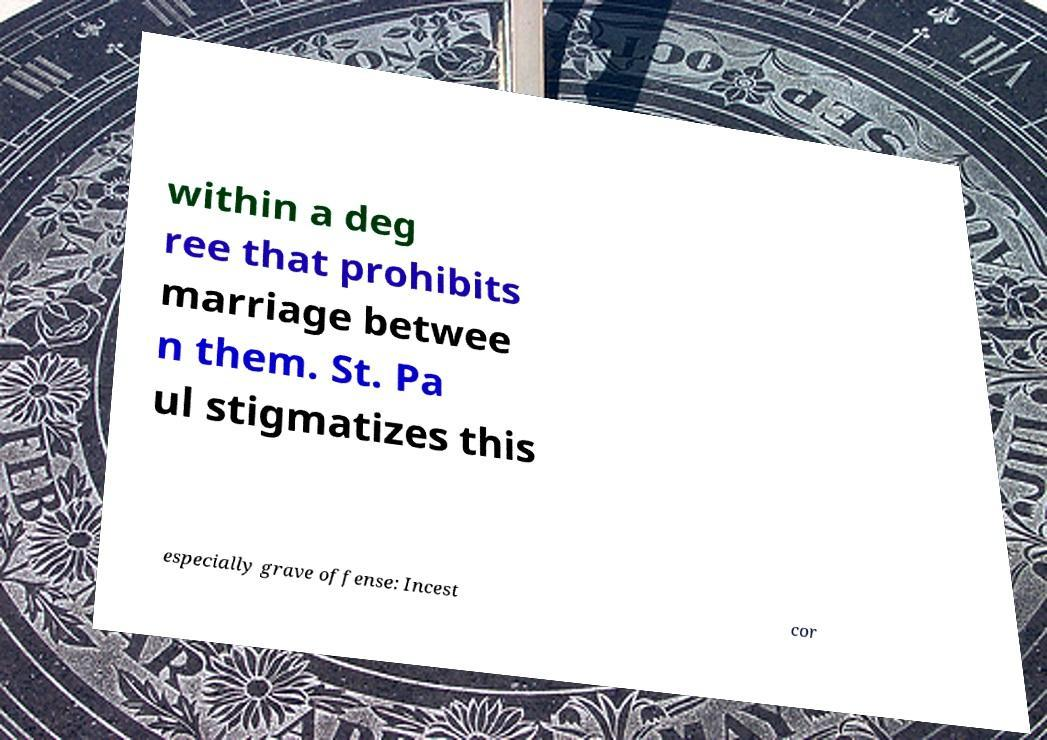For documentation purposes, I need the text within this image transcribed. Could you provide that? within a deg ree that prohibits marriage betwee n them. St. Pa ul stigmatizes this especially grave offense: Incest cor 